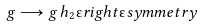<formula> <loc_0><loc_0><loc_500><loc_500>g \longrightarrow g \, h _ { 2 } " r i g h t " s y m m e t r y</formula> 